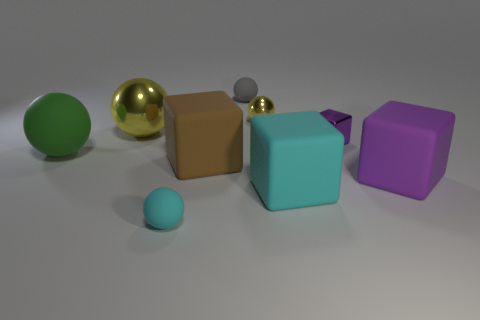Are there more big rubber cylinders than cyan things?
Ensure brevity in your answer.  No. There is a block on the left side of the gray ball; how many big things are to the right of it?
Make the answer very short. 2. How many things are shiny things that are to the right of the large brown object or small brown metal things?
Your answer should be very brief. 2. Is there another matte object of the same shape as the large brown matte thing?
Your answer should be very brief. Yes. What shape is the small matte thing that is on the left side of the rubber object behind the big green thing?
Keep it short and to the point. Sphere. What number of blocks are either large yellow objects or tiny yellow shiny things?
Provide a short and direct response. 0. There is a thing that is the same color as the small shiny cube; what is its material?
Your response must be concise. Rubber. Is the shape of the yellow shiny thing that is to the right of the big brown cube the same as the tiny object that is in front of the purple matte thing?
Your response must be concise. Yes. There is a cube that is on the right side of the big brown rubber block and behind the large purple rubber cube; what is its color?
Ensure brevity in your answer.  Purple. Does the big shiny sphere have the same color as the rubber sphere that is in front of the big green matte ball?
Give a very brief answer. No. 